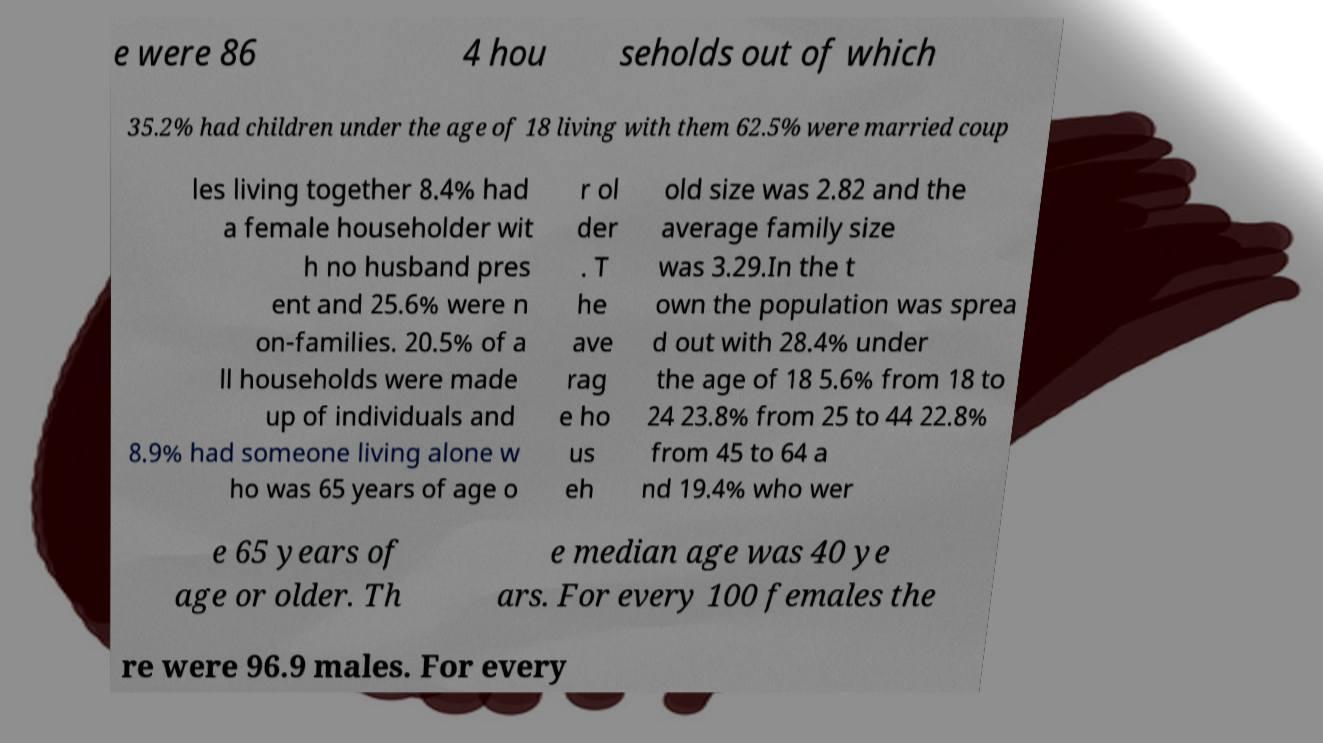What messages or text are displayed in this image? I need them in a readable, typed format. e were 86 4 hou seholds out of which 35.2% had children under the age of 18 living with them 62.5% were married coup les living together 8.4% had a female householder wit h no husband pres ent and 25.6% were n on-families. 20.5% of a ll households were made up of individuals and 8.9% had someone living alone w ho was 65 years of age o r ol der . T he ave rag e ho us eh old size was 2.82 and the average family size was 3.29.In the t own the population was sprea d out with 28.4% under the age of 18 5.6% from 18 to 24 23.8% from 25 to 44 22.8% from 45 to 64 a nd 19.4% who wer e 65 years of age or older. Th e median age was 40 ye ars. For every 100 females the re were 96.9 males. For every 